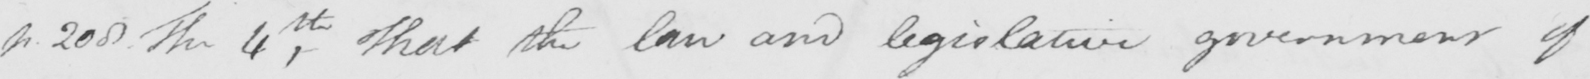Can you read and transcribe this handwriting? p . 208 The 4th , That the law and legislative government of 